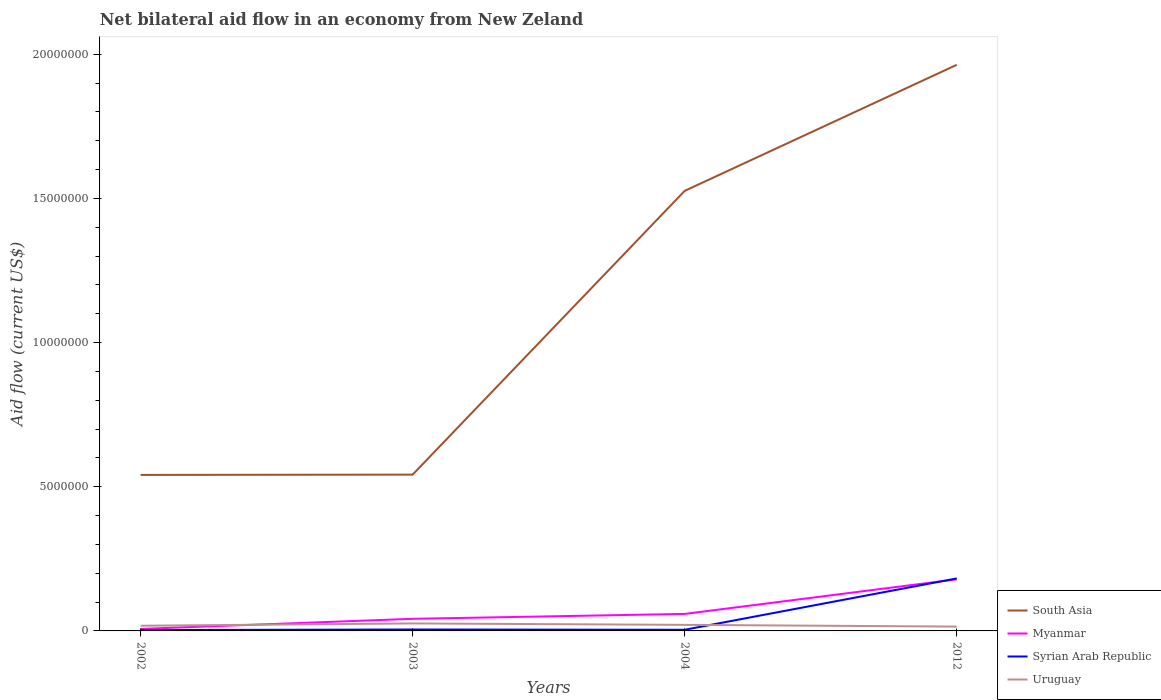How many different coloured lines are there?
Provide a short and direct response. 4. Is the number of lines equal to the number of legend labels?
Offer a terse response. Yes. Across all years, what is the maximum net bilateral aid flow in South Asia?
Make the answer very short. 5.41e+06. What is the total net bilateral aid flow in South Asia in the graph?
Offer a very short reply. -4.37e+06. What is the difference between the highest and the second highest net bilateral aid flow in Myanmar?
Provide a succinct answer. 1.72e+06. What is the difference between the highest and the lowest net bilateral aid flow in Syrian Arab Republic?
Offer a terse response. 1. How many lines are there?
Your answer should be compact. 4. What is the difference between two consecutive major ticks on the Y-axis?
Ensure brevity in your answer.  5.00e+06. Are the values on the major ticks of Y-axis written in scientific E-notation?
Provide a short and direct response. No. How many legend labels are there?
Ensure brevity in your answer.  4. What is the title of the graph?
Your response must be concise. Net bilateral aid flow in an economy from New Zeland. What is the label or title of the X-axis?
Provide a succinct answer. Years. What is the label or title of the Y-axis?
Offer a terse response. Aid flow (current US$). What is the Aid flow (current US$) in South Asia in 2002?
Make the answer very short. 5.41e+06. What is the Aid flow (current US$) of Uruguay in 2002?
Keep it short and to the point. 1.80e+05. What is the Aid flow (current US$) in South Asia in 2003?
Offer a very short reply. 5.42e+06. What is the Aid flow (current US$) in Myanmar in 2003?
Make the answer very short. 4.20e+05. What is the Aid flow (current US$) in South Asia in 2004?
Your response must be concise. 1.53e+07. What is the Aid flow (current US$) of Myanmar in 2004?
Ensure brevity in your answer.  5.90e+05. What is the Aid flow (current US$) in Uruguay in 2004?
Your answer should be very brief. 2.10e+05. What is the Aid flow (current US$) of South Asia in 2012?
Offer a terse response. 1.96e+07. What is the Aid flow (current US$) of Myanmar in 2012?
Offer a very short reply. 1.79e+06. What is the Aid flow (current US$) of Syrian Arab Republic in 2012?
Offer a terse response. 1.82e+06. Across all years, what is the maximum Aid flow (current US$) of South Asia?
Offer a terse response. 1.96e+07. Across all years, what is the maximum Aid flow (current US$) of Myanmar?
Ensure brevity in your answer.  1.79e+06. Across all years, what is the maximum Aid flow (current US$) in Syrian Arab Republic?
Make the answer very short. 1.82e+06. Across all years, what is the minimum Aid flow (current US$) of South Asia?
Give a very brief answer. 5.41e+06. Across all years, what is the minimum Aid flow (current US$) in Myanmar?
Make the answer very short. 7.00e+04. Across all years, what is the minimum Aid flow (current US$) in Uruguay?
Offer a terse response. 1.50e+05. What is the total Aid flow (current US$) of South Asia in the graph?
Give a very brief answer. 4.57e+07. What is the total Aid flow (current US$) of Myanmar in the graph?
Offer a very short reply. 2.87e+06. What is the total Aid flow (current US$) of Syrian Arab Republic in the graph?
Offer a terse response. 1.94e+06. What is the total Aid flow (current US$) of Uruguay in the graph?
Make the answer very short. 8.00e+05. What is the difference between the Aid flow (current US$) of South Asia in 2002 and that in 2003?
Offer a terse response. -10000. What is the difference between the Aid flow (current US$) of Myanmar in 2002 and that in 2003?
Your answer should be very brief. -3.50e+05. What is the difference between the Aid flow (current US$) in Syrian Arab Republic in 2002 and that in 2003?
Provide a succinct answer. -2.00e+04. What is the difference between the Aid flow (current US$) in South Asia in 2002 and that in 2004?
Offer a terse response. -9.85e+06. What is the difference between the Aid flow (current US$) in Myanmar in 2002 and that in 2004?
Your response must be concise. -5.20e+05. What is the difference between the Aid flow (current US$) of Uruguay in 2002 and that in 2004?
Offer a terse response. -3.00e+04. What is the difference between the Aid flow (current US$) of South Asia in 2002 and that in 2012?
Provide a short and direct response. -1.42e+07. What is the difference between the Aid flow (current US$) in Myanmar in 2002 and that in 2012?
Your answer should be compact. -1.72e+06. What is the difference between the Aid flow (current US$) of Syrian Arab Republic in 2002 and that in 2012?
Give a very brief answer. -1.79e+06. What is the difference between the Aid flow (current US$) in Uruguay in 2002 and that in 2012?
Offer a very short reply. 3.00e+04. What is the difference between the Aid flow (current US$) in South Asia in 2003 and that in 2004?
Provide a succinct answer. -9.84e+06. What is the difference between the Aid flow (current US$) in Syrian Arab Republic in 2003 and that in 2004?
Give a very brief answer. 10000. What is the difference between the Aid flow (current US$) of South Asia in 2003 and that in 2012?
Keep it short and to the point. -1.42e+07. What is the difference between the Aid flow (current US$) in Myanmar in 2003 and that in 2012?
Provide a short and direct response. -1.37e+06. What is the difference between the Aid flow (current US$) in Syrian Arab Republic in 2003 and that in 2012?
Offer a terse response. -1.77e+06. What is the difference between the Aid flow (current US$) of Uruguay in 2003 and that in 2012?
Your response must be concise. 1.10e+05. What is the difference between the Aid flow (current US$) of South Asia in 2004 and that in 2012?
Provide a succinct answer. -4.37e+06. What is the difference between the Aid flow (current US$) of Myanmar in 2004 and that in 2012?
Provide a succinct answer. -1.20e+06. What is the difference between the Aid flow (current US$) in Syrian Arab Republic in 2004 and that in 2012?
Your answer should be compact. -1.78e+06. What is the difference between the Aid flow (current US$) in South Asia in 2002 and the Aid flow (current US$) in Myanmar in 2003?
Your response must be concise. 4.99e+06. What is the difference between the Aid flow (current US$) in South Asia in 2002 and the Aid flow (current US$) in Syrian Arab Republic in 2003?
Ensure brevity in your answer.  5.36e+06. What is the difference between the Aid flow (current US$) in South Asia in 2002 and the Aid flow (current US$) in Uruguay in 2003?
Provide a succinct answer. 5.15e+06. What is the difference between the Aid flow (current US$) of Syrian Arab Republic in 2002 and the Aid flow (current US$) of Uruguay in 2003?
Give a very brief answer. -2.30e+05. What is the difference between the Aid flow (current US$) of South Asia in 2002 and the Aid flow (current US$) of Myanmar in 2004?
Your answer should be very brief. 4.82e+06. What is the difference between the Aid flow (current US$) of South Asia in 2002 and the Aid flow (current US$) of Syrian Arab Republic in 2004?
Your response must be concise. 5.37e+06. What is the difference between the Aid flow (current US$) of South Asia in 2002 and the Aid flow (current US$) of Uruguay in 2004?
Ensure brevity in your answer.  5.20e+06. What is the difference between the Aid flow (current US$) of Myanmar in 2002 and the Aid flow (current US$) of Syrian Arab Republic in 2004?
Provide a short and direct response. 3.00e+04. What is the difference between the Aid flow (current US$) in Myanmar in 2002 and the Aid flow (current US$) in Uruguay in 2004?
Make the answer very short. -1.40e+05. What is the difference between the Aid flow (current US$) in Syrian Arab Republic in 2002 and the Aid flow (current US$) in Uruguay in 2004?
Make the answer very short. -1.80e+05. What is the difference between the Aid flow (current US$) in South Asia in 2002 and the Aid flow (current US$) in Myanmar in 2012?
Offer a terse response. 3.62e+06. What is the difference between the Aid flow (current US$) of South Asia in 2002 and the Aid flow (current US$) of Syrian Arab Republic in 2012?
Your answer should be compact. 3.59e+06. What is the difference between the Aid flow (current US$) in South Asia in 2002 and the Aid flow (current US$) in Uruguay in 2012?
Offer a terse response. 5.26e+06. What is the difference between the Aid flow (current US$) of Myanmar in 2002 and the Aid flow (current US$) of Syrian Arab Republic in 2012?
Give a very brief answer. -1.75e+06. What is the difference between the Aid flow (current US$) in Myanmar in 2002 and the Aid flow (current US$) in Uruguay in 2012?
Your answer should be compact. -8.00e+04. What is the difference between the Aid flow (current US$) in South Asia in 2003 and the Aid flow (current US$) in Myanmar in 2004?
Your answer should be compact. 4.83e+06. What is the difference between the Aid flow (current US$) of South Asia in 2003 and the Aid flow (current US$) of Syrian Arab Republic in 2004?
Your answer should be very brief. 5.38e+06. What is the difference between the Aid flow (current US$) of South Asia in 2003 and the Aid flow (current US$) of Uruguay in 2004?
Offer a very short reply. 5.21e+06. What is the difference between the Aid flow (current US$) in Syrian Arab Republic in 2003 and the Aid flow (current US$) in Uruguay in 2004?
Your answer should be very brief. -1.60e+05. What is the difference between the Aid flow (current US$) of South Asia in 2003 and the Aid flow (current US$) of Myanmar in 2012?
Offer a very short reply. 3.63e+06. What is the difference between the Aid flow (current US$) in South Asia in 2003 and the Aid flow (current US$) in Syrian Arab Republic in 2012?
Offer a terse response. 3.60e+06. What is the difference between the Aid flow (current US$) in South Asia in 2003 and the Aid flow (current US$) in Uruguay in 2012?
Provide a short and direct response. 5.27e+06. What is the difference between the Aid flow (current US$) of Myanmar in 2003 and the Aid flow (current US$) of Syrian Arab Republic in 2012?
Ensure brevity in your answer.  -1.40e+06. What is the difference between the Aid flow (current US$) in South Asia in 2004 and the Aid flow (current US$) in Myanmar in 2012?
Provide a short and direct response. 1.35e+07. What is the difference between the Aid flow (current US$) in South Asia in 2004 and the Aid flow (current US$) in Syrian Arab Republic in 2012?
Give a very brief answer. 1.34e+07. What is the difference between the Aid flow (current US$) of South Asia in 2004 and the Aid flow (current US$) of Uruguay in 2012?
Offer a terse response. 1.51e+07. What is the difference between the Aid flow (current US$) of Myanmar in 2004 and the Aid flow (current US$) of Syrian Arab Republic in 2012?
Provide a short and direct response. -1.23e+06. What is the average Aid flow (current US$) of South Asia per year?
Make the answer very short. 1.14e+07. What is the average Aid flow (current US$) in Myanmar per year?
Make the answer very short. 7.18e+05. What is the average Aid flow (current US$) in Syrian Arab Republic per year?
Your answer should be very brief. 4.85e+05. In the year 2002, what is the difference between the Aid flow (current US$) in South Asia and Aid flow (current US$) in Myanmar?
Give a very brief answer. 5.34e+06. In the year 2002, what is the difference between the Aid flow (current US$) in South Asia and Aid flow (current US$) in Syrian Arab Republic?
Provide a short and direct response. 5.38e+06. In the year 2002, what is the difference between the Aid flow (current US$) in South Asia and Aid flow (current US$) in Uruguay?
Your answer should be very brief. 5.23e+06. In the year 2002, what is the difference between the Aid flow (current US$) of Myanmar and Aid flow (current US$) of Syrian Arab Republic?
Provide a succinct answer. 4.00e+04. In the year 2002, what is the difference between the Aid flow (current US$) in Myanmar and Aid flow (current US$) in Uruguay?
Your response must be concise. -1.10e+05. In the year 2003, what is the difference between the Aid flow (current US$) of South Asia and Aid flow (current US$) of Syrian Arab Republic?
Ensure brevity in your answer.  5.37e+06. In the year 2003, what is the difference between the Aid flow (current US$) in South Asia and Aid flow (current US$) in Uruguay?
Make the answer very short. 5.16e+06. In the year 2003, what is the difference between the Aid flow (current US$) in Syrian Arab Republic and Aid flow (current US$) in Uruguay?
Offer a terse response. -2.10e+05. In the year 2004, what is the difference between the Aid flow (current US$) in South Asia and Aid flow (current US$) in Myanmar?
Your answer should be compact. 1.47e+07. In the year 2004, what is the difference between the Aid flow (current US$) of South Asia and Aid flow (current US$) of Syrian Arab Republic?
Give a very brief answer. 1.52e+07. In the year 2004, what is the difference between the Aid flow (current US$) in South Asia and Aid flow (current US$) in Uruguay?
Ensure brevity in your answer.  1.50e+07. In the year 2004, what is the difference between the Aid flow (current US$) in Myanmar and Aid flow (current US$) in Syrian Arab Republic?
Keep it short and to the point. 5.50e+05. In the year 2004, what is the difference between the Aid flow (current US$) of Syrian Arab Republic and Aid flow (current US$) of Uruguay?
Provide a succinct answer. -1.70e+05. In the year 2012, what is the difference between the Aid flow (current US$) of South Asia and Aid flow (current US$) of Myanmar?
Keep it short and to the point. 1.78e+07. In the year 2012, what is the difference between the Aid flow (current US$) in South Asia and Aid flow (current US$) in Syrian Arab Republic?
Offer a very short reply. 1.78e+07. In the year 2012, what is the difference between the Aid flow (current US$) in South Asia and Aid flow (current US$) in Uruguay?
Provide a succinct answer. 1.95e+07. In the year 2012, what is the difference between the Aid flow (current US$) of Myanmar and Aid flow (current US$) of Syrian Arab Republic?
Make the answer very short. -3.00e+04. In the year 2012, what is the difference between the Aid flow (current US$) in Myanmar and Aid flow (current US$) in Uruguay?
Your answer should be compact. 1.64e+06. In the year 2012, what is the difference between the Aid flow (current US$) in Syrian Arab Republic and Aid flow (current US$) in Uruguay?
Provide a succinct answer. 1.67e+06. What is the ratio of the Aid flow (current US$) of Myanmar in 2002 to that in 2003?
Make the answer very short. 0.17. What is the ratio of the Aid flow (current US$) in Uruguay in 2002 to that in 2003?
Provide a succinct answer. 0.69. What is the ratio of the Aid flow (current US$) of South Asia in 2002 to that in 2004?
Keep it short and to the point. 0.35. What is the ratio of the Aid flow (current US$) in Myanmar in 2002 to that in 2004?
Give a very brief answer. 0.12. What is the ratio of the Aid flow (current US$) in Uruguay in 2002 to that in 2004?
Ensure brevity in your answer.  0.86. What is the ratio of the Aid flow (current US$) of South Asia in 2002 to that in 2012?
Provide a short and direct response. 0.28. What is the ratio of the Aid flow (current US$) in Myanmar in 2002 to that in 2012?
Provide a short and direct response. 0.04. What is the ratio of the Aid flow (current US$) in Syrian Arab Republic in 2002 to that in 2012?
Ensure brevity in your answer.  0.02. What is the ratio of the Aid flow (current US$) of Uruguay in 2002 to that in 2012?
Your answer should be very brief. 1.2. What is the ratio of the Aid flow (current US$) in South Asia in 2003 to that in 2004?
Your answer should be compact. 0.36. What is the ratio of the Aid flow (current US$) of Myanmar in 2003 to that in 2004?
Keep it short and to the point. 0.71. What is the ratio of the Aid flow (current US$) of Uruguay in 2003 to that in 2004?
Your answer should be very brief. 1.24. What is the ratio of the Aid flow (current US$) in South Asia in 2003 to that in 2012?
Keep it short and to the point. 0.28. What is the ratio of the Aid flow (current US$) in Myanmar in 2003 to that in 2012?
Make the answer very short. 0.23. What is the ratio of the Aid flow (current US$) of Syrian Arab Republic in 2003 to that in 2012?
Your answer should be very brief. 0.03. What is the ratio of the Aid flow (current US$) in Uruguay in 2003 to that in 2012?
Ensure brevity in your answer.  1.73. What is the ratio of the Aid flow (current US$) in South Asia in 2004 to that in 2012?
Offer a terse response. 0.78. What is the ratio of the Aid flow (current US$) of Myanmar in 2004 to that in 2012?
Your answer should be compact. 0.33. What is the ratio of the Aid flow (current US$) of Syrian Arab Republic in 2004 to that in 2012?
Your answer should be compact. 0.02. What is the difference between the highest and the second highest Aid flow (current US$) of South Asia?
Offer a terse response. 4.37e+06. What is the difference between the highest and the second highest Aid flow (current US$) in Myanmar?
Make the answer very short. 1.20e+06. What is the difference between the highest and the second highest Aid flow (current US$) in Syrian Arab Republic?
Offer a very short reply. 1.77e+06. What is the difference between the highest and the lowest Aid flow (current US$) in South Asia?
Your response must be concise. 1.42e+07. What is the difference between the highest and the lowest Aid flow (current US$) in Myanmar?
Offer a terse response. 1.72e+06. What is the difference between the highest and the lowest Aid flow (current US$) in Syrian Arab Republic?
Ensure brevity in your answer.  1.79e+06. 